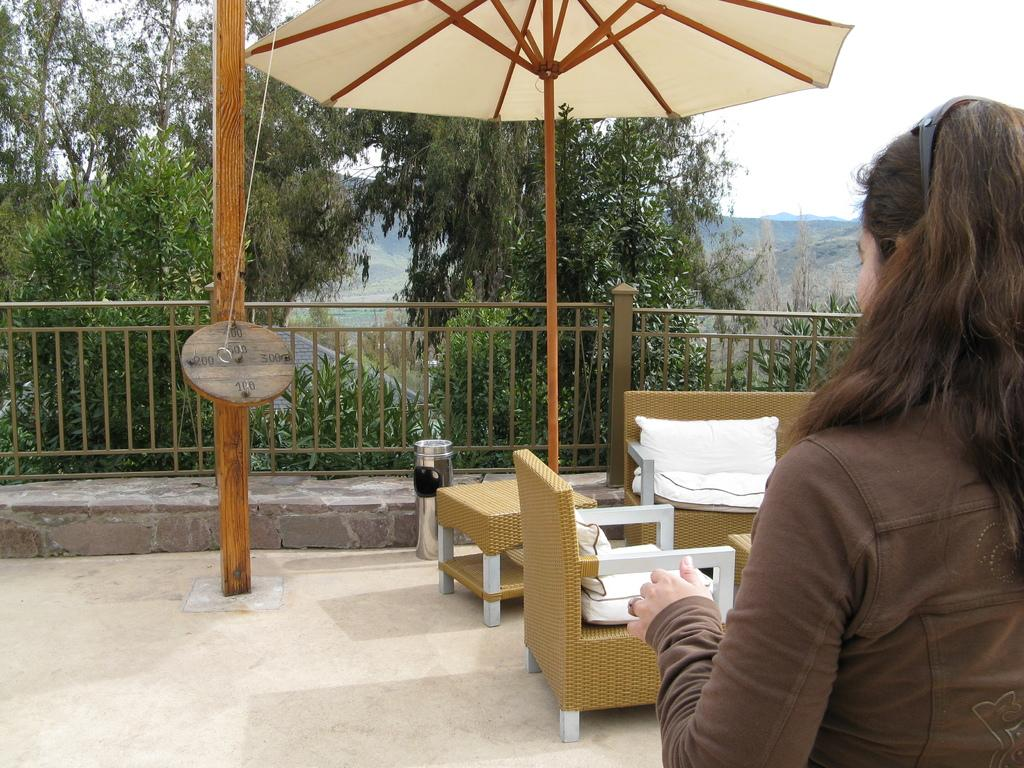Where was the image taken? The image is taken outdoors. Can you describe the lady in the image? There is a lady standing on the right side of the image. What furniture is in front of the lady? There is a sofa and chairs in front of the lady. What can be seen in the background of the image? There are trees, hills, and the sky visible in the background of the image. What type of butter is stored in the jar on the table in the image? There is no jar or butter present in the image. How many trains can be seen passing by in the image? There are no trains visible in the image. 